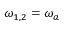<formula> <loc_0><loc_0><loc_500><loc_500>\omega _ { 1 , 2 } = \omega _ { a }</formula> 